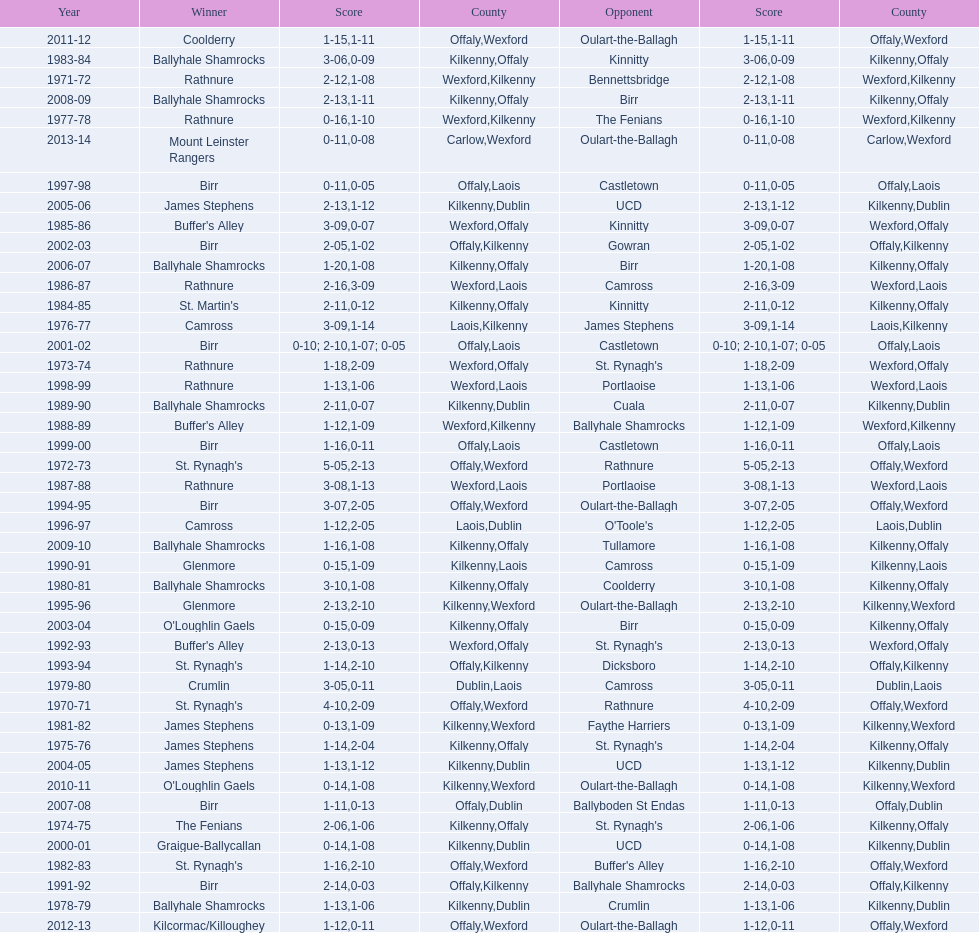Help me parse the entirety of this table. {'header': ['Year', 'Winner', 'Score', 'County', 'Opponent', 'Score', 'County'], 'rows': [['2011-12', 'Coolderry', '1-15', 'Offaly', 'Oulart-the-Ballagh', '1-11', 'Wexford'], ['1983-84', 'Ballyhale Shamrocks', '3-06', 'Kilkenny', 'Kinnitty', '0-09', 'Offaly'], ['1971-72', 'Rathnure', '2-12', 'Wexford', 'Bennettsbridge', '1-08', 'Kilkenny'], ['2008-09', 'Ballyhale Shamrocks', '2-13', 'Kilkenny', 'Birr', '1-11', 'Offaly'], ['1977-78', 'Rathnure', '0-16', 'Wexford', 'The Fenians', '1-10', 'Kilkenny'], ['2013-14', 'Mount Leinster Rangers', '0-11', 'Carlow', 'Oulart-the-Ballagh', '0-08', 'Wexford'], ['1997-98', 'Birr', '0-11', 'Offaly', 'Castletown', '0-05', 'Laois'], ['2005-06', 'James Stephens', '2-13', 'Kilkenny', 'UCD', '1-12', 'Dublin'], ['1985-86', "Buffer's Alley", '3-09', 'Wexford', 'Kinnitty', '0-07', 'Offaly'], ['2002-03', 'Birr', '2-05', 'Offaly', 'Gowran', '1-02', 'Kilkenny'], ['2006-07', 'Ballyhale Shamrocks', '1-20', 'Kilkenny', 'Birr', '1-08', 'Offaly'], ['1986-87', 'Rathnure', '2-16', 'Wexford', 'Camross', '3-09', 'Laois'], ['1984-85', "St. Martin's", '2-11', 'Kilkenny', 'Kinnitty', '0-12', 'Offaly'], ['1976-77', 'Camross', '3-09', 'Laois', 'James Stephens', '1-14', 'Kilkenny'], ['2001-02', 'Birr', '0-10; 2-10', 'Offaly', 'Castletown', '1-07; 0-05', 'Laois'], ['1973-74', 'Rathnure', '1-18', 'Wexford', "St. Rynagh's", '2-09', 'Offaly'], ['1998-99', 'Rathnure', '1-13', 'Wexford', 'Portlaoise', '1-06', 'Laois'], ['1989-90', 'Ballyhale Shamrocks', '2-11', 'Kilkenny', 'Cuala', '0-07', 'Dublin'], ['1988-89', "Buffer's Alley", '1-12', 'Wexford', 'Ballyhale Shamrocks', '1-09', 'Kilkenny'], ['1999-00', 'Birr', '1-16', 'Offaly', 'Castletown', '0-11', 'Laois'], ['1972-73', "St. Rynagh's", '5-05', 'Offaly', 'Rathnure', '2-13', 'Wexford'], ['1987-88', 'Rathnure', '3-08', 'Wexford', 'Portlaoise', '1-13', 'Laois'], ['1994-95', 'Birr', '3-07', 'Offaly', 'Oulart-the-Ballagh', '2-05', 'Wexford'], ['1996-97', 'Camross', '1-12', 'Laois', "O'Toole's", '2-05', 'Dublin'], ['2009-10', 'Ballyhale Shamrocks', '1-16', 'Kilkenny', 'Tullamore', '1-08', 'Offaly'], ['1990-91', 'Glenmore', '0-15', 'Kilkenny', 'Camross', '1-09', 'Laois'], ['1980-81', 'Ballyhale Shamrocks', '3-10', 'Kilkenny', 'Coolderry', '1-08', 'Offaly'], ['1995-96', 'Glenmore', '2-13', 'Kilkenny', 'Oulart-the-Ballagh', '2-10', 'Wexford'], ['2003-04', "O'Loughlin Gaels", '0-15', 'Kilkenny', 'Birr', '0-09', 'Offaly'], ['1992-93', "Buffer's Alley", '2-13', 'Wexford', "St. Rynagh's", '0-13', 'Offaly'], ['1993-94', "St. Rynagh's", '1-14', 'Offaly', 'Dicksboro', '2-10', 'Kilkenny'], ['1979-80', 'Crumlin', '3-05', 'Dublin', 'Camross', '0-11', 'Laois'], ['1970-71', "St. Rynagh's", '4-10', 'Offaly', 'Rathnure', '2-09', 'Wexford'], ['1981-82', 'James Stephens', '0-13', 'Kilkenny', 'Faythe Harriers', '1-09', 'Wexford'], ['1975-76', 'James Stephens', '1-14', 'Kilkenny', "St. Rynagh's", '2-04', 'Offaly'], ['2004-05', 'James Stephens', '1-13', 'Kilkenny', 'UCD', '1-12', 'Dublin'], ['2010-11', "O'Loughlin Gaels", '0-14', 'Kilkenny', 'Oulart-the-Ballagh', '1-08', 'Wexford'], ['2007-08', 'Birr', '1-11', 'Offaly', 'Ballyboden St Endas', '0-13', 'Dublin'], ['1974-75', 'The Fenians', '2-06', 'Kilkenny', "St. Rynagh's", '1-06', 'Offaly'], ['2000-01', 'Graigue-Ballycallan', '0-14', 'Kilkenny', 'UCD', '1-08', 'Dublin'], ['1982-83', "St. Rynagh's", '1-16', 'Offaly', "Buffer's Alley", '2-10', 'Wexford'], ['1991-92', 'Birr', '2-14', 'Offaly', 'Ballyhale Shamrocks', '0-03', 'Kilkenny'], ['1978-79', 'Ballyhale Shamrocks', '1-13', 'Kilkenny', 'Crumlin', '1-06', 'Dublin'], ['2012-13', 'Kilcormac/Killoughey', '1-12', 'Offaly', 'Oulart-the-Ballagh', '0-11', 'Wexford']]} What was the last season the leinster senior club hurling championships was won by a score differential of less than 11? 2007-08. 